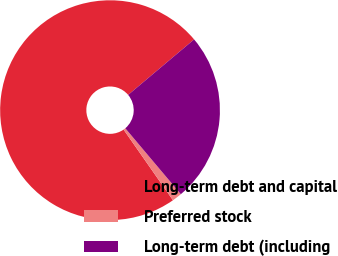Convert chart to OTSL. <chart><loc_0><loc_0><loc_500><loc_500><pie_chart><fcel>Long-term debt and capital<fcel>Preferred stock<fcel>Long-term debt (including<nl><fcel>73.57%<fcel>1.44%<fcel>24.99%<nl></chart> 